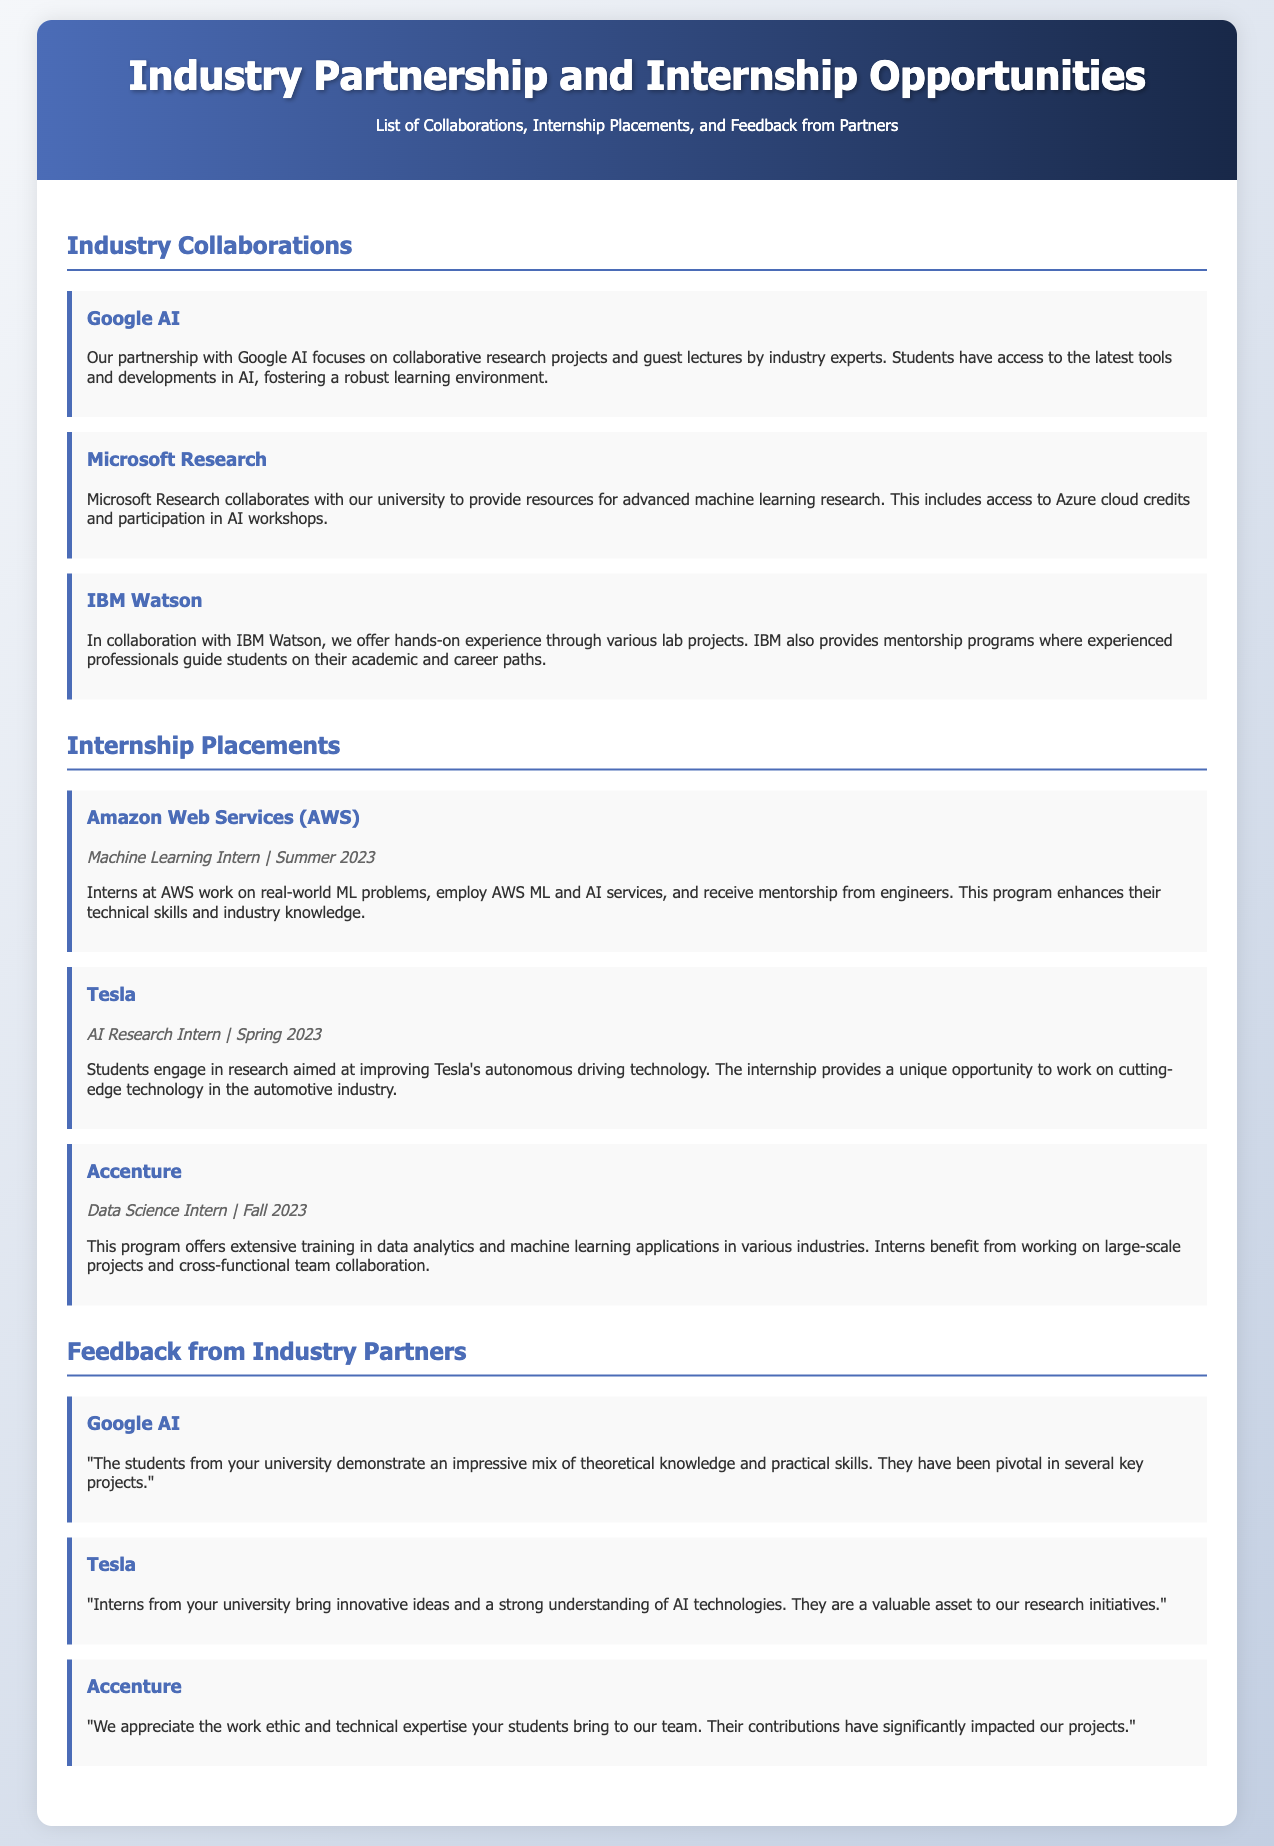What is the title of the document? The title of the document is mentioned in the header.
Answer: Industry Partnership and Internship Opportunities Who partners with the university for AI research? The document lists several industry collaborations including Google AI and Microsoft Research.
Answer: Google AI What feedback did Google AI provide about students? The document includes feedback from industry partners regarding the performance of students.
Answer: "impressive mix of theoretical knowledge and practical skills" Which company offers a Data Science internship in Fall 2023? The document indicates the companies that provide internships along with their respective timings.
Answer: Accenture How many collaborations are listed in the document? By counting the industry collaborations mentioned in the document's section, we find the total.
Answer: Three What unique opportunity does the Tesla internship provide? The document highlights specific focuses of the internships to indicate their uniqueness.
Answer: improving Tesla's autonomous driving technology Where can feedback from industry partners be found? The document has a specific section dedicated to feedback, categorized accordingly.
Answer: Feedback from Industry Partners 